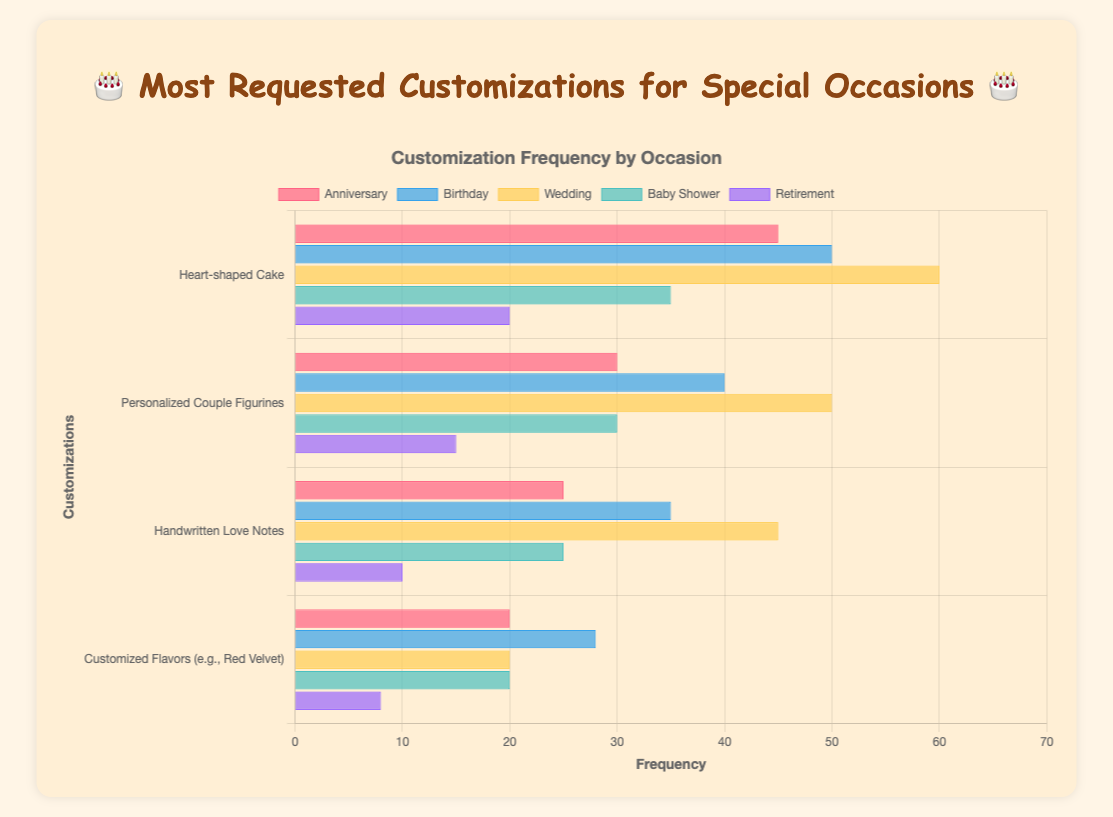Which occasion has the highest requested customization frequency? The Wedding category has the Multi-tier Cakes customization, which has a frequency of 60, the highest among all customizations listed.
Answer: Wedding Compare the most requested customizations for Birthdays and Anniversaries. For Birthdays, the most requested customization is Photo Cakes with a frequency of 50. For Anniversaries, the most requested is Heart-shaped Cake with a frequency of 45. Photo Cakes for Birthdays have a higher frequency.
Answer: Photo Cakes Which customization has the lowest frequency in the Retirement category? The Retirement category shows Unique Designs (e.g., rocking chairs) with the lowest frequency at 8.
Answer: Unique Designs What is the combined frequency of Handwritten Love Notes and Customized Flavors for Anniversaries? Handwritten Love Notes has a frequency of 25 and Customized Flavors has a frequency of 20. Their combined frequency is 25 + 20 = 45.
Answer: 45 What are the top two most frequently requested customizations? The two customizations with the highest frequency are Multi-tier Cakes for Weddings (60) and Photo Cakes for Birthdays (50).
Answer: Multi-tier Cakes and Photo Cakes Which category has the smallest range between its highest and lowest frequency customizations? The Baby Shower category has customizations with frequencies ranging from 35 (Gender Reveal Cakes) to 20 (Animal Figurines), giving a range of 15, which is smaller than the ranges in other categories.
Answer: Baby Shower How much more frequently is Gender Reveal Cakes requested compared to Animal Figurines in Baby Showers? Gender Reveal Cakes have a frequency of 35 and Animal Figurines have a frequency of 20. The difference is 35 - 20 = 15.
Answer: 15 Which customization for Weddings is requested as frequently as the least requested customization for Anniversaries? Both Gold Leaf Accents for Weddings and Customized Flavors for Anniversaries have a frequency of 20.
Answer: Gold Leaf Accents What is the average frequency of customizations across all categories? Total frequency is (45+30+25+20) + (50+40+35+28) + (60+50+45+20) + (35+30+25+20) + (20+15+10+8) = 656. There are 20 customizations, so the average is 656/20 = 32.8.
Answer: 32.8 What's the sum of the frequencies of all customizations that involve the word "Cake"? The relevant frequencies are Heart-shaped Cake (45), Photo Cakes (50), Multi-tier Cakes (60), and Gender Reveal Cakes (35). The sum is 45 + 50 + 60 + 35 = 190.
Answer: 190 